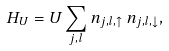<formula> <loc_0><loc_0><loc_500><loc_500>H _ { U } = U \sum _ { j , l } n _ { j , l , \uparrow } \, n _ { j , l , \downarrow } ,</formula> 